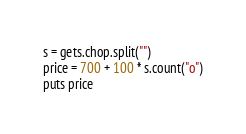<code> <loc_0><loc_0><loc_500><loc_500><_Ruby_>s = gets.chop.split("")
price = 700 + 100 * s.count("o")
puts price
</code> 